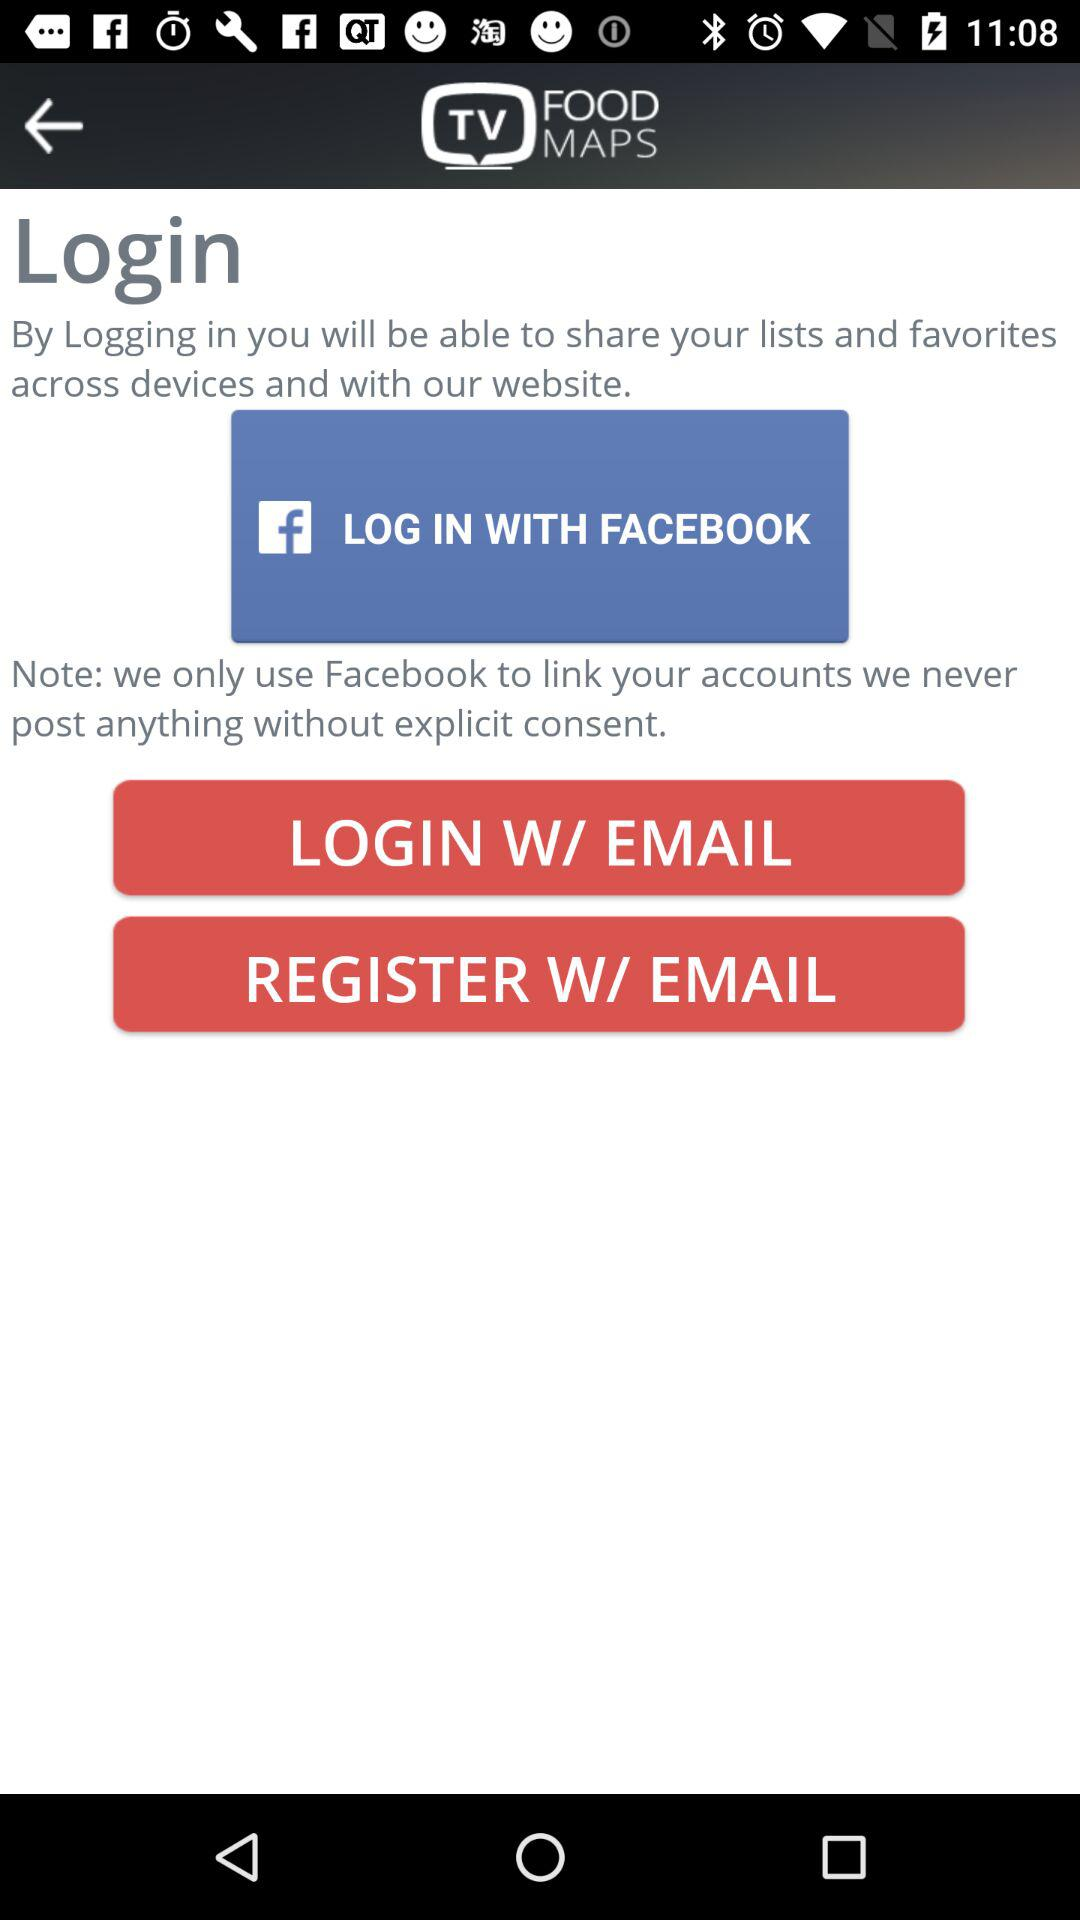What application is used for login? The application that is used for login is Facebook. 